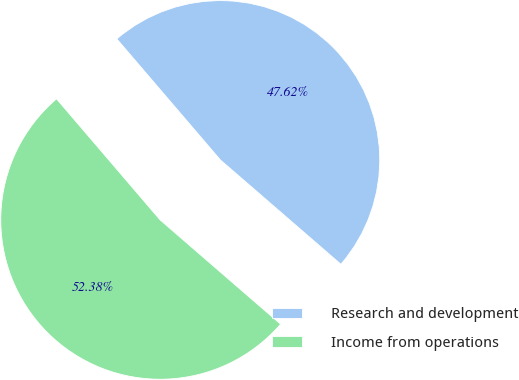<chart> <loc_0><loc_0><loc_500><loc_500><pie_chart><fcel>Research and development<fcel>Income from operations<nl><fcel>47.62%<fcel>52.38%<nl></chart> 